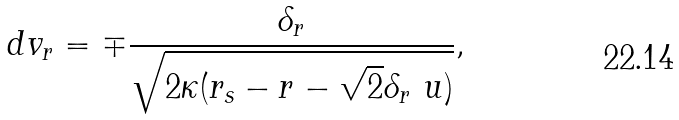<formula> <loc_0><loc_0><loc_500><loc_500>d v _ { r } = \mp \frac { \delta _ { r } } { \sqrt { 2 \kappa ( r _ { s } - r - \sqrt { 2 } \delta _ { r } \ u ) } } ,</formula> 